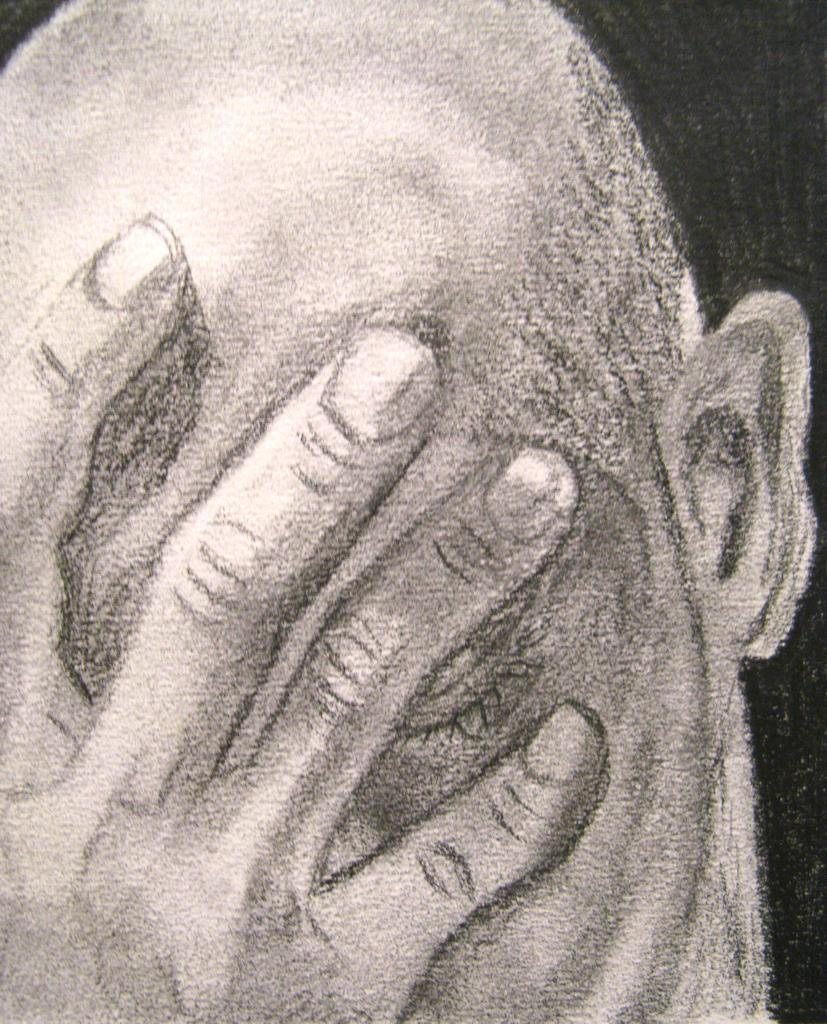What is the main subject of the image? There is a sketch in the image. How many passengers are visible in the sketch? There are no passengers present in the image, as it only contains a sketch. What type of plantation is depicted in the sketch? There is no plantation depicted in the sketch, as it only contains a sketch. 